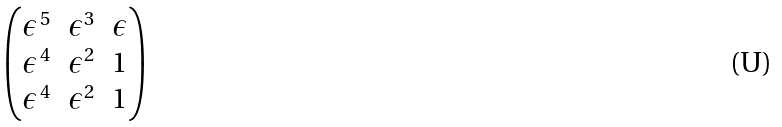<formula> <loc_0><loc_0><loc_500><loc_500>\begin{pmatrix} \epsilon ^ { \, 5 } & \epsilon ^ { 3 } & \epsilon \\ \epsilon ^ { \, 4 } & \epsilon ^ { 2 } & 1 \\ \epsilon ^ { \, 4 } & \epsilon ^ { 2 } & 1 \end{pmatrix}</formula> 